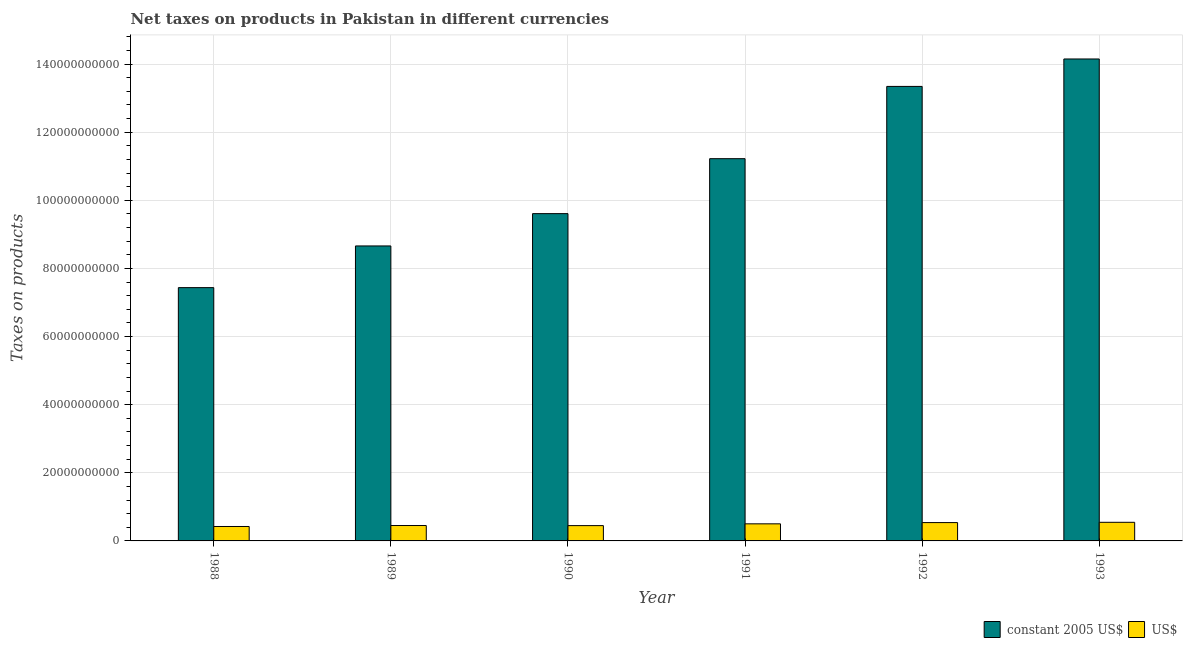Are the number of bars on each tick of the X-axis equal?
Give a very brief answer. Yes. How many bars are there on the 4th tick from the left?
Keep it short and to the point. 2. How many bars are there on the 4th tick from the right?
Provide a short and direct response. 2. What is the label of the 1st group of bars from the left?
Keep it short and to the point. 1988. What is the net taxes in us$ in 1992?
Make the answer very short. 5.38e+09. Across all years, what is the maximum net taxes in constant 2005 us$?
Offer a very short reply. 1.42e+11. Across all years, what is the minimum net taxes in us$?
Your response must be concise. 4.24e+09. In which year was the net taxes in us$ minimum?
Provide a short and direct response. 1988. What is the total net taxes in us$ in the graph?
Offer a terse response. 2.91e+1. What is the difference between the net taxes in constant 2005 us$ in 1989 and that in 1991?
Your answer should be very brief. -2.56e+1. What is the difference between the net taxes in us$ in 1988 and the net taxes in constant 2005 us$ in 1990?
Your response must be concise. -2.56e+08. What is the average net taxes in us$ per year?
Provide a short and direct response. 4.85e+09. In how many years, is the net taxes in constant 2005 us$ greater than 12000000000 units?
Give a very brief answer. 6. What is the ratio of the net taxes in us$ in 1988 to that in 1990?
Your answer should be very brief. 0.94. Is the net taxes in constant 2005 us$ in 1988 less than that in 1992?
Your response must be concise. Yes. Is the difference between the net taxes in us$ in 1992 and 1993 greater than the difference between the net taxes in constant 2005 us$ in 1992 and 1993?
Your answer should be very brief. No. What is the difference between the highest and the second highest net taxes in us$?
Ensure brevity in your answer.  7.94e+07. What is the difference between the highest and the lowest net taxes in us$?
Offer a terse response. 1.23e+09. Is the sum of the net taxes in constant 2005 us$ in 1990 and 1993 greater than the maximum net taxes in us$ across all years?
Your answer should be very brief. Yes. What does the 2nd bar from the left in 1989 represents?
Offer a very short reply. US$. What does the 1st bar from the right in 1989 represents?
Offer a terse response. US$. How many bars are there?
Provide a succinct answer. 12. Does the graph contain any zero values?
Your response must be concise. No. How many legend labels are there?
Your answer should be compact. 2. What is the title of the graph?
Provide a succinct answer. Net taxes on products in Pakistan in different currencies. What is the label or title of the X-axis?
Ensure brevity in your answer.  Year. What is the label or title of the Y-axis?
Your answer should be very brief. Taxes on products. What is the Taxes on products of constant 2005 US$ in 1988?
Offer a terse response. 7.44e+1. What is the Taxes on products of US$ in 1988?
Keep it short and to the point. 4.24e+09. What is the Taxes on products of constant 2005 US$ in 1989?
Offer a very short reply. 8.66e+1. What is the Taxes on products of US$ in 1989?
Your answer should be very brief. 4.52e+09. What is the Taxes on products in constant 2005 US$ in 1990?
Offer a terse response. 9.61e+1. What is the Taxes on products of US$ in 1990?
Make the answer very short. 4.49e+09. What is the Taxes on products in constant 2005 US$ in 1991?
Your response must be concise. 1.12e+11. What is the Taxes on products in US$ in 1991?
Your answer should be very brief. 5.02e+09. What is the Taxes on products in constant 2005 US$ in 1992?
Your response must be concise. 1.33e+11. What is the Taxes on products in US$ in 1992?
Your response must be concise. 5.38e+09. What is the Taxes on products in constant 2005 US$ in 1993?
Give a very brief answer. 1.42e+11. What is the Taxes on products in US$ in 1993?
Your response must be concise. 5.46e+09. Across all years, what is the maximum Taxes on products of constant 2005 US$?
Offer a very short reply. 1.42e+11. Across all years, what is the maximum Taxes on products in US$?
Offer a terse response. 5.46e+09. Across all years, what is the minimum Taxes on products of constant 2005 US$?
Provide a succinct answer. 7.44e+1. Across all years, what is the minimum Taxes on products in US$?
Give a very brief answer. 4.24e+09. What is the total Taxes on products of constant 2005 US$ in the graph?
Ensure brevity in your answer.  6.44e+11. What is the total Taxes on products in US$ in the graph?
Your answer should be compact. 2.91e+1. What is the difference between the Taxes on products in constant 2005 US$ in 1988 and that in 1989?
Your answer should be compact. -1.22e+1. What is the difference between the Taxes on products in US$ in 1988 and that in 1989?
Your answer should be compact. -2.84e+08. What is the difference between the Taxes on products of constant 2005 US$ in 1988 and that in 1990?
Make the answer very short. -2.17e+1. What is the difference between the Taxes on products in US$ in 1988 and that in 1990?
Offer a terse response. -2.56e+08. What is the difference between the Taxes on products in constant 2005 US$ in 1988 and that in 1991?
Offer a terse response. -3.79e+1. What is the difference between the Taxes on products in US$ in 1988 and that in 1991?
Your answer should be compact. -7.81e+08. What is the difference between the Taxes on products of constant 2005 US$ in 1988 and that in 1992?
Ensure brevity in your answer.  -5.91e+1. What is the difference between the Taxes on products in US$ in 1988 and that in 1992?
Your answer should be very brief. -1.15e+09. What is the difference between the Taxes on products of constant 2005 US$ in 1988 and that in 1993?
Make the answer very short. -6.71e+1. What is the difference between the Taxes on products in US$ in 1988 and that in 1993?
Make the answer very short. -1.23e+09. What is the difference between the Taxes on products of constant 2005 US$ in 1989 and that in 1990?
Provide a short and direct response. -9.48e+09. What is the difference between the Taxes on products in US$ in 1989 and that in 1990?
Ensure brevity in your answer.  2.80e+07. What is the difference between the Taxes on products in constant 2005 US$ in 1989 and that in 1991?
Offer a very short reply. -2.56e+1. What is the difference between the Taxes on products of US$ in 1989 and that in 1991?
Provide a short and direct response. -4.97e+08. What is the difference between the Taxes on products in constant 2005 US$ in 1989 and that in 1992?
Your response must be concise. -4.68e+1. What is the difference between the Taxes on products in US$ in 1989 and that in 1992?
Offer a terse response. -8.65e+08. What is the difference between the Taxes on products of constant 2005 US$ in 1989 and that in 1993?
Your answer should be very brief. -5.49e+1. What is the difference between the Taxes on products of US$ in 1989 and that in 1993?
Offer a terse response. -9.45e+08. What is the difference between the Taxes on products of constant 2005 US$ in 1990 and that in 1991?
Your response must be concise. -1.61e+1. What is the difference between the Taxes on products of US$ in 1990 and that in 1991?
Provide a succinct answer. -5.25e+08. What is the difference between the Taxes on products of constant 2005 US$ in 1990 and that in 1992?
Offer a very short reply. -3.74e+1. What is the difference between the Taxes on products of US$ in 1990 and that in 1992?
Your answer should be very brief. -8.93e+08. What is the difference between the Taxes on products of constant 2005 US$ in 1990 and that in 1993?
Keep it short and to the point. -4.54e+1. What is the difference between the Taxes on products in US$ in 1990 and that in 1993?
Ensure brevity in your answer.  -9.73e+08. What is the difference between the Taxes on products in constant 2005 US$ in 1991 and that in 1992?
Provide a succinct answer. -2.12e+1. What is the difference between the Taxes on products in US$ in 1991 and that in 1992?
Your answer should be compact. -3.68e+08. What is the difference between the Taxes on products in constant 2005 US$ in 1991 and that in 1993?
Your answer should be compact. -2.93e+1. What is the difference between the Taxes on products of US$ in 1991 and that in 1993?
Provide a succinct answer. -4.47e+08. What is the difference between the Taxes on products in constant 2005 US$ in 1992 and that in 1993?
Keep it short and to the point. -8.06e+09. What is the difference between the Taxes on products of US$ in 1992 and that in 1993?
Ensure brevity in your answer.  -7.94e+07. What is the difference between the Taxes on products in constant 2005 US$ in 1988 and the Taxes on products in US$ in 1989?
Provide a short and direct response. 6.98e+1. What is the difference between the Taxes on products in constant 2005 US$ in 1988 and the Taxes on products in US$ in 1990?
Give a very brief answer. 6.99e+1. What is the difference between the Taxes on products of constant 2005 US$ in 1988 and the Taxes on products of US$ in 1991?
Your answer should be compact. 6.93e+1. What is the difference between the Taxes on products in constant 2005 US$ in 1988 and the Taxes on products in US$ in 1992?
Your response must be concise. 6.90e+1. What is the difference between the Taxes on products of constant 2005 US$ in 1988 and the Taxes on products of US$ in 1993?
Offer a terse response. 6.89e+1. What is the difference between the Taxes on products in constant 2005 US$ in 1989 and the Taxes on products in US$ in 1990?
Your response must be concise. 8.21e+1. What is the difference between the Taxes on products in constant 2005 US$ in 1989 and the Taxes on products in US$ in 1991?
Give a very brief answer. 8.16e+1. What is the difference between the Taxes on products in constant 2005 US$ in 1989 and the Taxes on products in US$ in 1992?
Provide a succinct answer. 8.12e+1. What is the difference between the Taxes on products in constant 2005 US$ in 1989 and the Taxes on products in US$ in 1993?
Give a very brief answer. 8.11e+1. What is the difference between the Taxes on products in constant 2005 US$ in 1990 and the Taxes on products in US$ in 1991?
Make the answer very short. 9.11e+1. What is the difference between the Taxes on products in constant 2005 US$ in 1990 and the Taxes on products in US$ in 1992?
Keep it short and to the point. 9.07e+1. What is the difference between the Taxes on products in constant 2005 US$ in 1990 and the Taxes on products in US$ in 1993?
Offer a terse response. 9.06e+1. What is the difference between the Taxes on products in constant 2005 US$ in 1991 and the Taxes on products in US$ in 1992?
Provide a short and direct response. 1.07e+11. What is the difference between the Taxes on products in constant 2005 US$ in 1991 and the Taxes on products in US$ in 1993?
Offer a terse response. 1.07e+11. What is the difference between the Taxes on products in constant 2005 US$ in 1992 and the Taxes on products in US$ in 1993?
Your answer should be compact. 1.28e+11. What is the average Taxes on products of constant 2005 US$ per year?
Provide a succinct answer. 1.07e+11. What is the average Taxes on products in US$ per year?
Give a very brief answer. 4.85e+09. In the year 1988, what is the difference between the Taxes on products in constant 2005 US$ and Taxes on products in US$?
Make the answer very short. 7.01e+1. In the year 1989, what is the difference between the Taxes on products in constant 2005 US$ and Taxes on products in US$?
Make the answer very short. 8.21e+1. In the year 1990, what is the difference between the Taxes on products in constant 2005 US$ and Taxes on products in US$?
Make the answer very short. 9.16e+1. In the year 1991, what is the difference between the Taxes on products in constant 2005 US$ and Taxes on products in US$?
Your answer should be very brief. 1.07e+11. In the year 1992, what is the difference between the Taxes on products in constant 2005 US$ and Taxes on products in US$?
Ensure brevity in your answer.  1.28e+11. In the year 1993, what is the difference between the Taxes on products in constant 2005 US$ and Taxes on products in US$?
Provide a short and direct response. 1.36e+11. What is the ratio of the Taxes on products of constant 2005 US$ in 1988 to that in 1989?
Your answer should be very brief. 0.86. What is the ratio of the Taxes on products in US$ in 1988 to that in 1989?
Keep it short and to the point. 0.94. What is the ratio of the Taxes on products of constant 2005 US$ in 1988 to that in 1990?
Your answer should be very brief. 0.77. What is the ratio of the Taxes on products of US$ in 1988 to that in 1990?
Provide a succinct answer. 0.94. What is the ratio of the Taxes on products in constant 2005 US$ in 1988 to that in 1991?
Make the answer very short. 0.66. What is the ratio of the Taxes on products of US$ in 1988 to that in 1991?
Give a very brief answer. 0.84. What is the ratio of the Taxes on products in constant 2005 US$ in 1988 to that in 1992?
Keep it short and to the point. 0.56. What is the ratio of the Taxes on products in US$ in 1988 to that in 1992?
Give a very brief answer. 0.79. What is the ratio of the Taxes on products of constant 2005 US$ in 1988 to that in 1993?
Give a very brief answer. 0.53. What is the ratio of the Taxes on products of US$ in 1988 to that in 1993?
Provide a succinct answer. 0.78. What is the ratio of the Taxes on products in constant 2005 US$ in 1989 to that in 1990?
Provide a short and direct response. 0.9. What is the ratio of the Taxes on products of constant 2005 US$ in 1989 to that in 1991?
Give a very brief answer. 0.77. What is the ratio of the Taxes on products in US$ in 1989 to that in 1991?
Your response must be concise. 0.9. What is the ratio of the Taxes on products in constant 2005 US$ in 1989 to that in 1992?
Keep it short and to the point. 0.65. What is the ratio of the Taxes on products of US$ in 1989 to that in 1992?
Keep it short and to the point. 0.84. What is the ratio of the Taxes on products in constant 2005 US$ in 1989 to that in 1993?
Offer a terse response. 0.61. What is the ratio of the Taxes on products in US$ in 1989 to that in 1993?
Your answer should be very brief. 0.83. What is the ratio of the Taxes on products of constant 2005 US$ in 1990 to that in 1991?
Give a very brief answer. 0.86. What is the ratio of the Taxes on products in US$ in 1990 to that in 1991?
Provide a short and direct response. 0.9. What is the ratio of the Taxes on products of constant 2005 US$ in 1990 to that in 1992?
Keep it short and to the point. 0.72. What is the ratio of the Taxes on products in US$ in 1990 to that in 1992?
Your answer should be very brief. 0.83. What is the ratio of the Taxes on products in constant 2005 US$ in 1990 to that in 1993?
Your answer should be very brief. 0.68. What is the ratio of the Taxes on products of US$ in 1990 to that in 1993?
Provide a short and direct response. 0.82. What is the ratio of the Taxes on products in constant 2005 US$ in 1991 to that in 1992?
Keep it short and to the point. 0.84. What is the ratio of the Taxes on products in US$ in 1991 to that in 1992?
Keep it short and to the point. 0.93. What is the ratio of the Taxes on products of constant 2005 US$ in 1991 to that in 1993?
Offer a very short reply. 0.79. What is the ratio of the Taxes on products of US$ in 1991 to that in 1993?
Your answer should be very brief. 0.92. What is the ratio of the Taxes on products of constant 2005 US$ in 1992 to that in 1993?
Ensure brevity in your answer.  0.94. What is the ratio of the Taxes on products of US$ in 1992 to that in 1993?
Provide a succinct answer. 0.99. What is the difference between the highest and the second highest Taxes on products in constant 2005 US$?
Keep it short and to the point. 8.06e+09. What is the difference between the highest and the second highest Taxes on products in US$?
Keep it short and to the point. 7.94e+07. What is the difference between the highest and the lowest Taxes on products of constant 2005 US$?
Your response must be concise. 6.71e+1. What is the difference between the highest and the lowest Taxes on products in US$?
Offer a very short reply. 1.23e+09. 